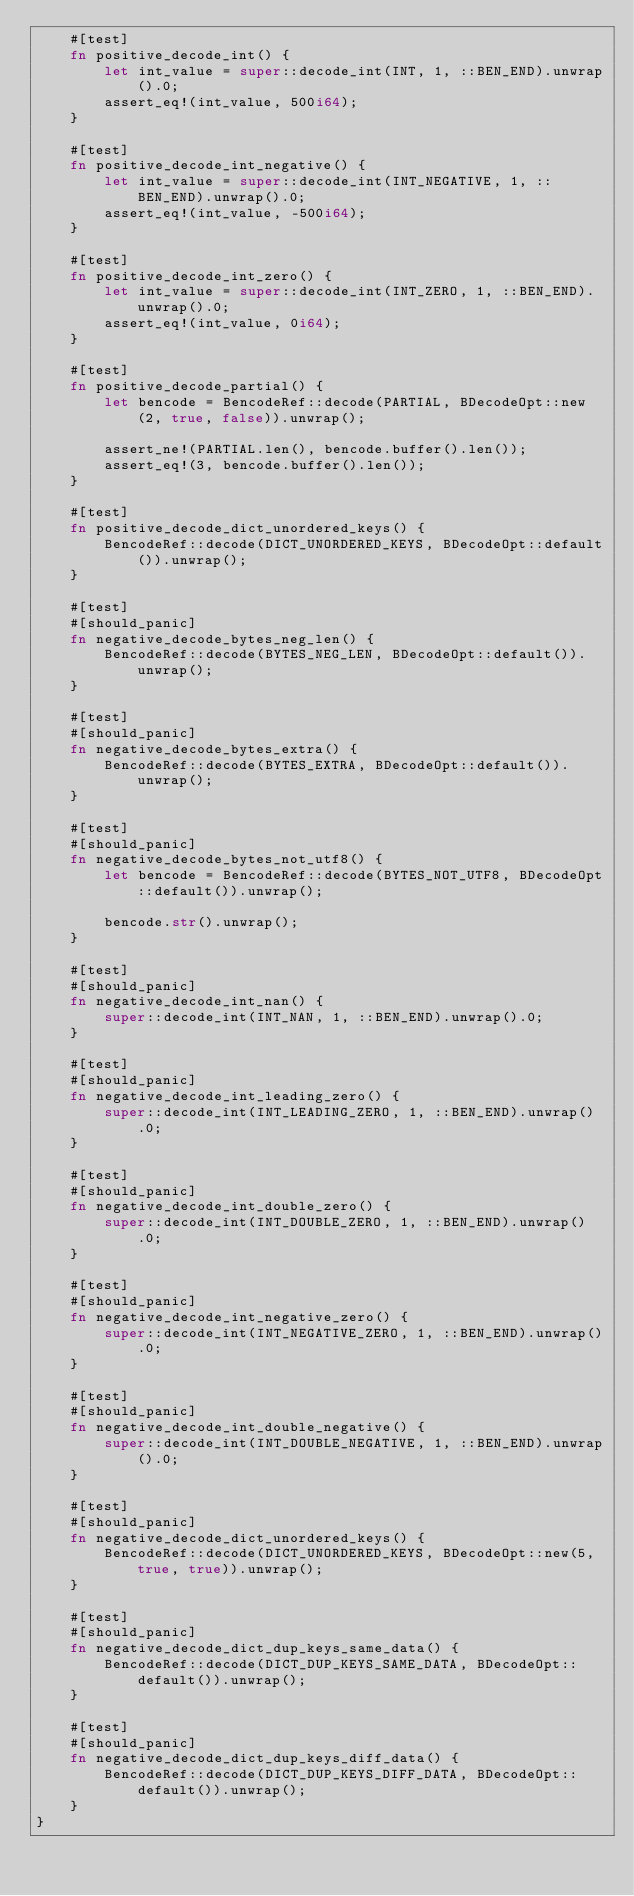Convert code to text. <code><loc_0><loc_0><loc_500><loc_500><_Rust_>    #[test]
    fn positive_decode_int() {
        let int_value = super::decode_int(INT, 1, ::BEN_END).unwrap().0;
        assert_eq!(int_value, 500i64);
    }

    #[test]
    fn positive_decode_int_negative() {
        let int_value = super::decode_int(INT_NEGATIVE, 1, ::BEN_END).unwrap().0;
        assert_eq!(int_value, -500i64);
    }

    #[test]
    fn positive_decode_int_zero() {
        let int_value = super::decode_int(INT_ZERO, 1, ::BEN_END).unwrap().0;
        assert_eq!(int_value, 0i64);
    }

    #[test]
    fn positive_decode_partial() {
        let bencode = BencodeRef::decode(PARTIAL, BDecodeOpt::new(2, true, false)).unwrap();

        assert_ne!(PARTIAL.len(), bencode.buffer().len());
        assert_eq!(3, bencode.buffer().len());
    }

    #[test]
    fn positive_decode_dict_unordered_keys() {
        BencodeRef::decode(DICT_UNORDERED_KEYS, BDecodeOpt::default()).unwrap();
    }

    #[test]
    #[should_panic]
    fn negative_decode_bytes_neg_len() {
        BencodeRef::decode(BYTES_NEG_LEN, BDecodeOpt::default()).unwrap();
    }

    #[test]
    #[should_panic]
    fn negative_decode_bytes_extra() {
        BencodeRef::decode(BYTES_EXTRA, BDecodeOpt::default()).unwrap();
    }

    #[test]
    #[should_panic]
    fn negative_decode_bytes_not_utf8() {
        let bencode = BencodeRef::decode(BYTES_NOT_UTF8, BDecodeOpt::default()).unwrap();

        bencode.str().unwrap();
    }

    #[test]
    #[should_panic]
    fn negative_decode_int_nan() {
        super::decode_int(INT_NAN, 1, ::BEN_END).unwrap().0;
    }

    #[test]
    #[should_panic]
    fn negative_decode_int_leading_zero() {
        super::decode_int(INT_LEADING_ZERO, 1, ::BEN_END).unwrap().0;
    }

    #[test]
    #[should_panic]
    fn negative_decode_int_double_zero() {
        super::decode_int(INT_DOUBLE_ZERO, 1, ::BEN_END).unwrap().0;
    }

    #[test]
    #[should_panic]
    fn negative_decode_int_negative_zero() {
        super::decode_int(INT_NEGATIVE_ZERO, 1, ::BEN_END).unwrap().0;
    }

    #[test]
    #[should_panic]
    fn negative_decode_int_double_negative() {
        super::decode_int(INT_DOUBLE_NEGATIVE, 1, ::BEN_END).unwrap().0;
    }

    #[test]
    #[should_panic]
    fn negative_decode_dict_unordered_keys() {
        BencodeRef::decode(DICT_UNORDERED_KEYS, BDecodeOpt::new(5, true, true)).unwrap();
    }

    #[test]
    #[should_panic]
    fn negative_decode_dict_dup_keys_same_data() {
        BencodeRef::decode(DICT_DUP_KEYS_SAME_DATA, BDecodeOpt::default()).unwrap();
    }

    #[test]
    #[should_panic]
    fn negative_decode_dict_dup_keys_diff_data() {
        BencodeRef::decode(DICT_DUP_KEYS_DIFF_DATA, BDecodeOpt::default()).unwrap();
    }
}
</code> 